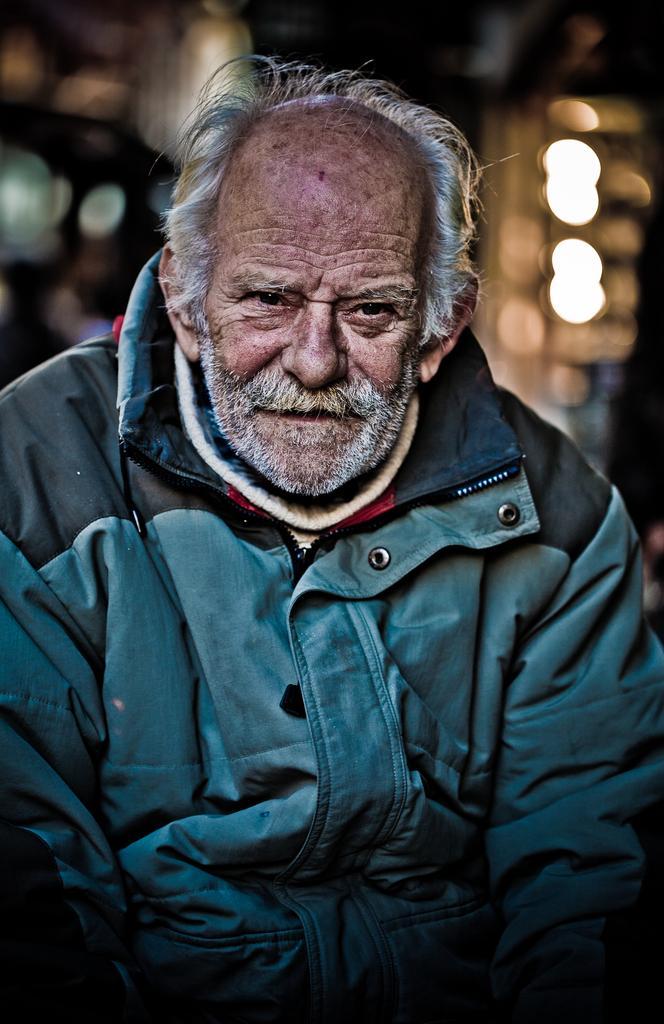Please provide a concise description of this image. In this image we can see an old man where he wore a blue color jacket. 